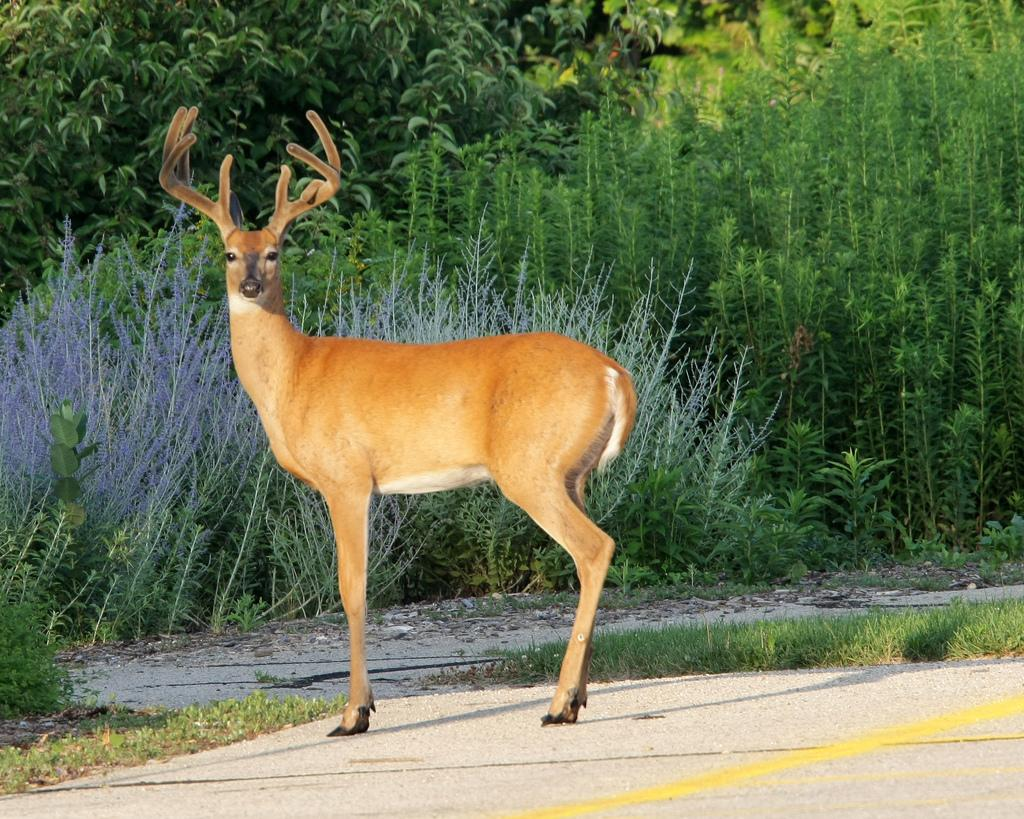What animal can be seen in the image? There is a deer in the image. What type of vegetation is visible in the background of the image? There are plants and trees in the background of the image. What is covering the ground in the image? There is grass on the ground in the image. Is the deer using an umbrella to protect itself from the rain in the image? There is no rain or umbrella present in the image, and the deer is not using any form of protection. 